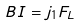<formula> <loc_0><loc_0><loc_500><loc_500>B I = j _ { 1 } F _ { L }</formula> 